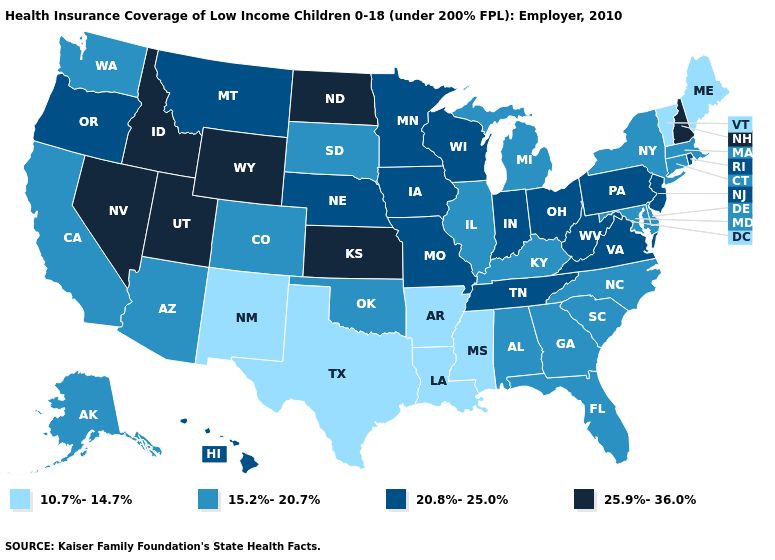Does North Dakota have the highest value in the USA?
Short answer required. Yes. Among the states that border New York , does Vermont have the lowest value?
Answer briefly. Yes. Is the legend a continuous bar?
Keep it brief. No. What is the highest value in states that border Wyoming?
Quick response, please. 25.9%-36.0%. Does Missouri have a lower value than California?
Concise answer only. No. What is the lowest value in the USA?
Keep it brief. 10.7%-14.7%. Name the states that have a value in the range 20.8%-25.0%?
Write a very short answer. Hawaii, Indiana, Iowa, Minnesota, Missouri, Montana, Nebraska, New Jersey, Ohio, Oregon, Pennsylvania, Rhode Island, Tennessee, Virginia, West Virginia, Wisconsin. What is the value of California?
Write a very short answer. 15.2%-20.7%. Among the states that border Minnesota , which have the highest value?
Concise answer only. North Dakota. What is the value of Arkansas?
Answer briefly. 10.7%-14.7%. Among the states that border California , does Arizona have the lowest value?
Concise answer only. Yes. What is the value of Georgia?
Short answer required. 15.2%-20.7%. Among the states that border Ohio , does Kentucky have the lowest value?
Write a very short answer. Yes. What is the highest value in the USA?
Give a very brief answer. 25.9%-36.0%. 